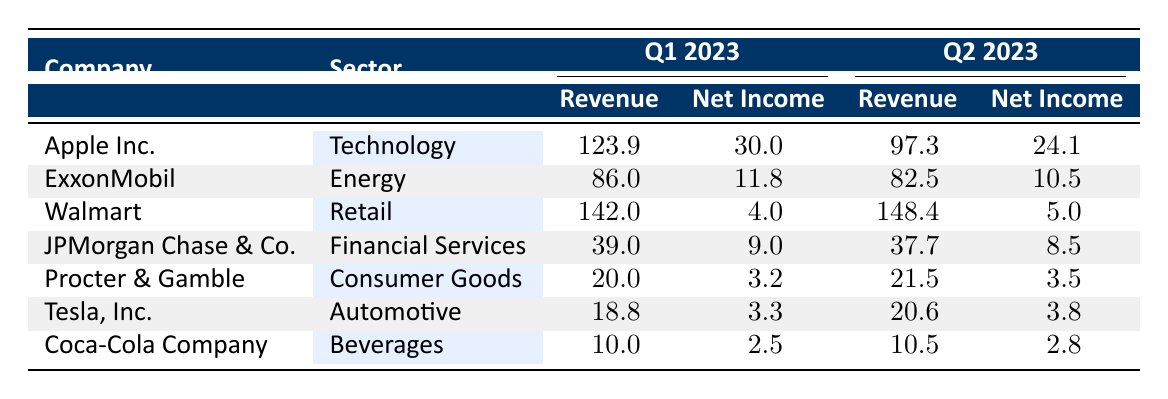What was Apple's net income in Q1 2023? The table shows Apple's figures for Q1 2023 where the net income is listed as 30.0.
Answer: 30.0 How much revenue did Walmart generate in Q2 2023? In the table, Walmart's revenue for Q2 2023 is recorded as 148.4.
Answer: 148.4 Which company had the highest net income in Q1 2023? By comparing the net incomes from the table, Apple Inc. had the highest net income at 30.0.
Answer: Apple Inc How much did ExxonMobil's revenue decline from Q1 to Q2 2023? ExxonMobil's revenue for Q1 2023 was 86.0, and for Q2 2023 it was 82.5. The decline can be calculated as 86.0 - 82.5 = 3.5.
Answer: 3.5 What is the average net income of Tesla, Inc., and Procter & Gamble in Q2 2023? Tesla, Inc. had a net income of 3.8 and Procter & Gamble had 3.5. The average can be calculated as (3.8 + 3.5) / 2 = 3.65.
Answer: 3.65 Did Coca-Cola Company's revenue increase from Q1 to Q2 2023? The revenue for Coca-Cola in Q1 2023 is 10.0, while in Q2 2023 it is 10.5. Since 10.5 > 10.0, the revenue did increase.
Answer: Yes Which sector had the lowest average revenue for Q1 2023? The revenue figures for Q1 2023 are: Apple (123.9), ExxonMobil (86.0), Walmart (142.0), JPMorgan Chase (39.0), Procter & Gamble (20.0), Tesla (18.8), Coca-Cola (10.0). The lowest average comes from 10.0 / 1, hence Coca-Cola's sector is the lowest.
Answer: Beverages What was the total revenue for all companies in Q1 2023? By adding all revenues in Q1: (123.9 + 86.0 + 142.0 + 39.0 + 20.0 + 18.8 + 10.0) = 420.7.
Answer: 420.7 Did any company report higher net income in Q2 2023 compared to Q1 2023? Comparing each company's Q1 and Q2 net incomes, Procter & Gamble, Tesla, and Coca-Cola all showed no increase, while Apple, Exxonmobil, Walmart and JPMorgan Chase did see declines. Hence none had higher net income.
Answer: No What is the percentage decrease in net income for JPMorgan Chase from Q1 to Q2 2023? JPMorgan Chase had a net income of 9.0 in Q1 and 8.5 in Q2. The decrease is 9.0 - 8.5 = 0.5. To find the percentage decrease: (0.5 / 9.0) * 100 = 5.56%.
Answer: 5.56% 